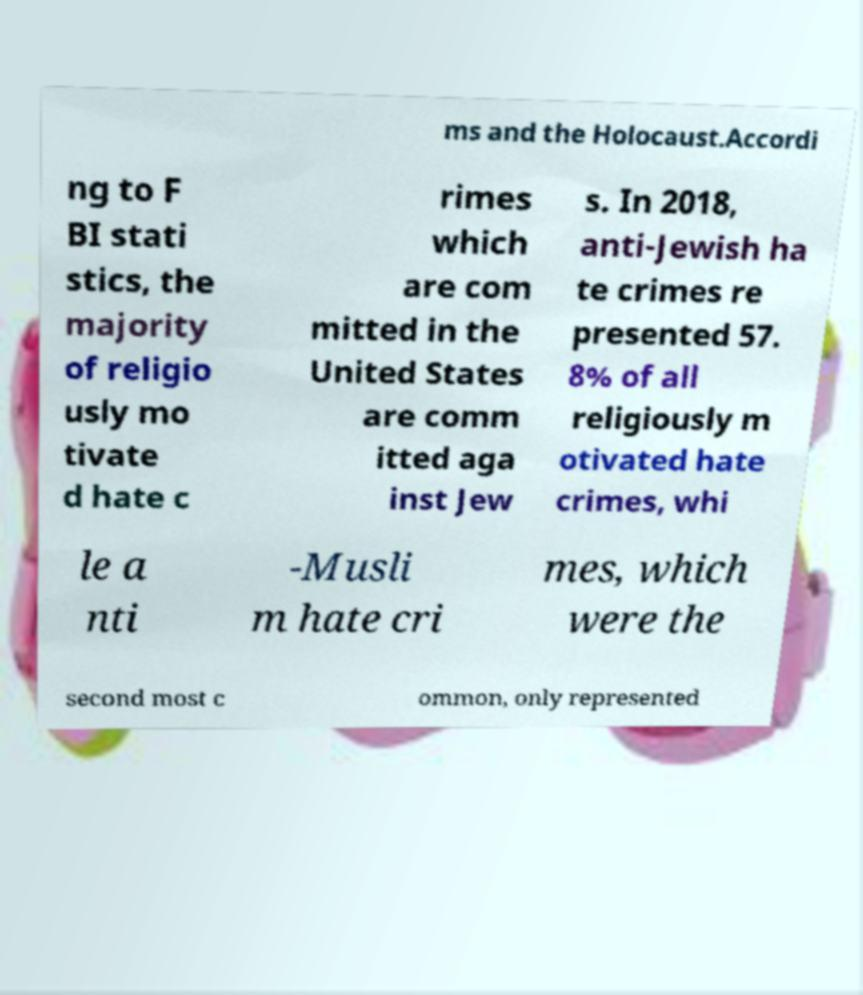Please identify and transcribe the text found in this image. ms and the Holocaust.Accordi ng to F BI stati stics, the majority of religio usly mo tivate d hate c rimes which are com mitted in the United States are comm itted aga inst Jew s. In 2018, anti-Jewish ha te crimes re presented 57. 8% of all religiously m otivated hate crimes, whi le a nti -Musli m hate cri mes, which were the second most c ommon, only represented 